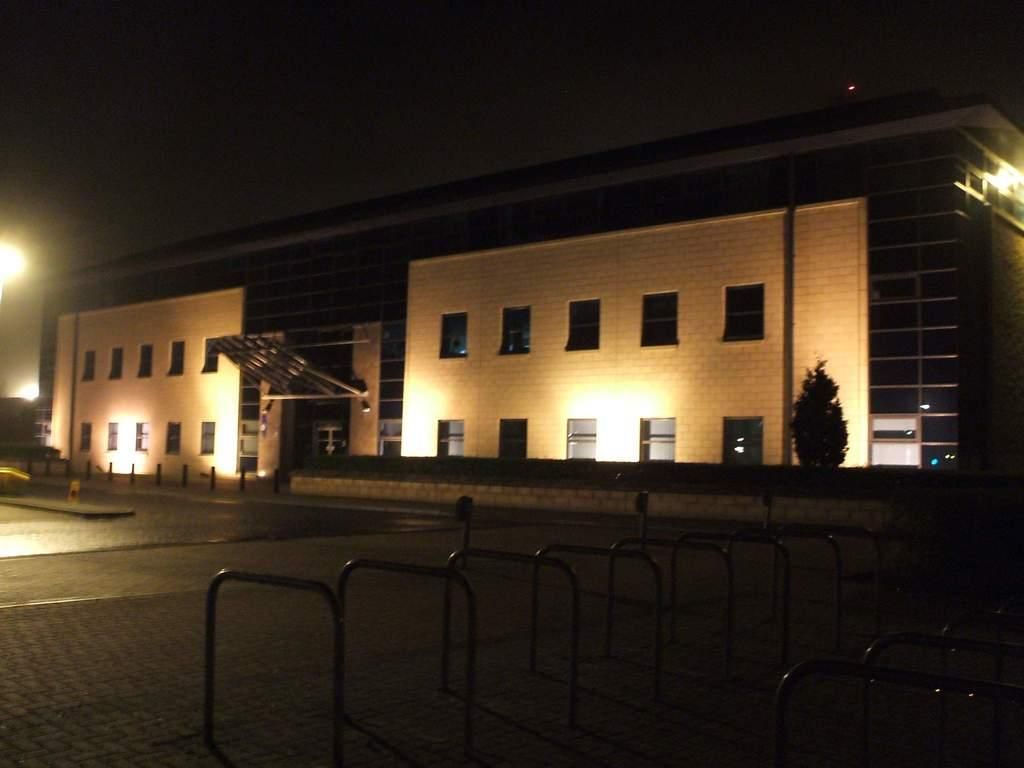What type of structure is present in the image? There is a building in the image. What can be seen illuminated in the image? There are lights visible in the image. What type of natural element is present in the image? There is a tree in the image. What type of man-made objects can be seen in the image? There are poles in the image. What else is present in the image besides the mentioned objects? There are other objects in the image. What is visible in the background of the image? The sky is visible in the background of the image. What type of authority figure can be seen in the image? There is no authority figure present in the image. What type of office furniture can be seen in the image? There is no office furniture present in the image. 